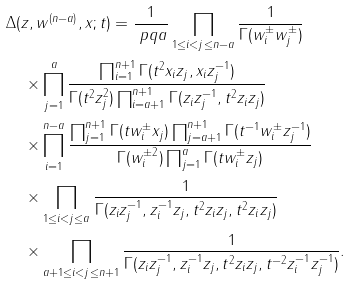<formula> <loc_0><loc_0><loc_500><loc_500>& \Delta ( z , w ^ { ( n - a ) } , x ; t ) = \frac { 1 } { \ p q { a } } \prod _ { 1 \leq i < j \leq n - a } \frac { 1 } { \Gamma ( w _ { i } ^ { \pm } w _ { j } ^ { \pm } ) } \\ & \quad \times \prod _ { j = 1 } ^ { a } \frac { \prod _ { i = 1 } ^ { n + 1 } \Gamma ( t ^ { 2 } x _ { i } z _ { j } , x _ { i } z _ { j } ^ { - 1 } ) } { \Gamma ( t ^ { 2 } z _ { j } ^ { 2 } ) \prod _ { i = a + 1 } ^ { n + 1 } \Gamma ( z _ { i } z _ { j } ^ { - 1 } , t ^ { 2 } z _ { i } z _ { j } ) } \\ & \quad \times \prod _ { i = 1 } ^ { n - a } \frac { \prod _ { j = 1 } ^ { n + 1 } \Gamma ( t w _ { i } ^ { \pm } x _ { j } ) \prod _ { j = a + 1 } ^ { n + 1 } \Gamma ( t ^ { - 1 } w _ { i } ^ { \pm } z _ { j } ^ { - 1 } ) } { \Gamma ( w _ { i } ^ { \pm 2 } ) \prod _ { j = 1 } ^ { a } \Gamma ( t w _ { i } ^ { \pm } z _ { j } ) } \\ & \quad \times \prod _ { 1 \leq i < j \leq a } \frac { 1 } { \Gamma ( z _ { i } z _ { j } ^ { - 1 } , z _ { i } ^ { - 1 } z _ { j } , t ^ { 2 } z _ { i } z _ { j } , t ^ { 2 } z _ { i } z _ { j } ) } \\ & \quad \times \prod _ { a + 1 \leq i < j \leq n + 1 } \frac { 1 } { \Gamma ( z _ { i } z _ { j } ^ { - 1 } , z _ { i } ^ { - 1 } z _ { j } , t ^ { 2 } z _ { i } z _ { j } , t ^ { - 2 } z _ { i } ^ { - 1 } z _ { j } ^ { - 1 } ) } .</formula> 